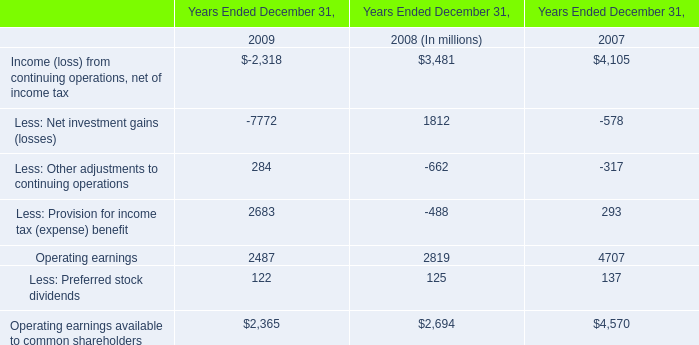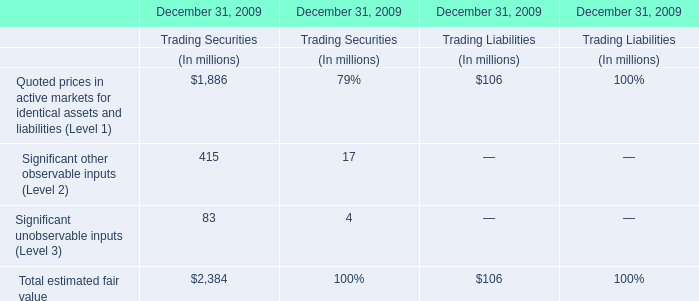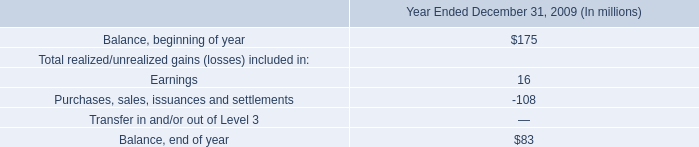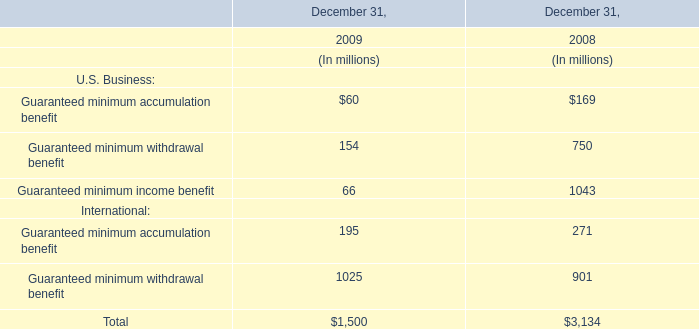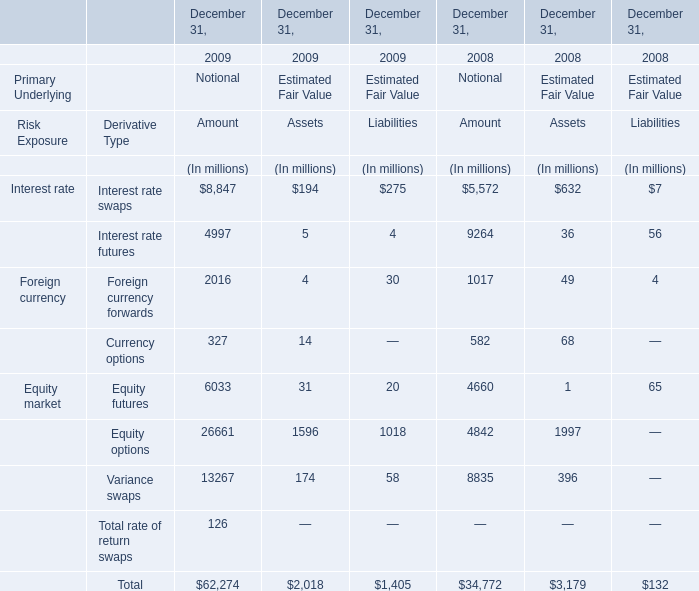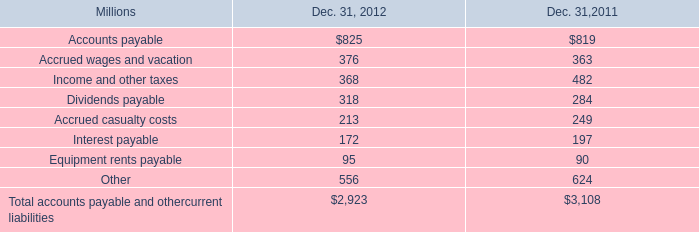What was the sum of U.S. Business without those U.S. Business smaller than 200 ( in 2018)? (in million) 
Computations: (750 + 1043)
Answer: 1793.0. 